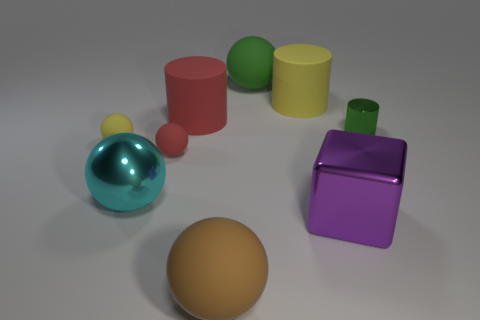Are there any objects in the image that look similar? What features make them seem alike? Yes, there are a couple of pairs of similar objects. The red and yellow cylinders share the same shape but differ in size and color, while the two spheres—one green, one bronze—have the same shape but are distinct in size and color. 